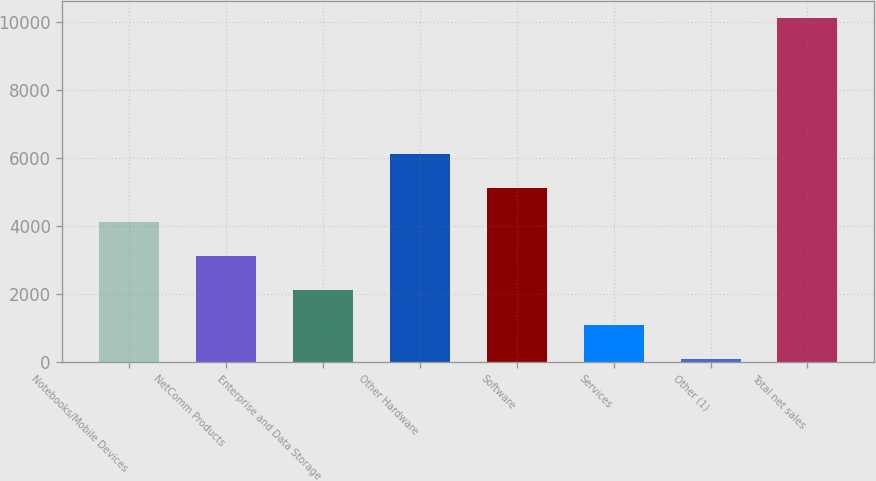<chart> <loc_0><loc_0><loc_500><loc_500><bar_chart><fcel>Notebooks/Mobile Devices<fcel>NetComm Products<fcel>Enterprise and Data Storage<fcel>Other Hardware<fcel>Software<fcel>Services<fcel>Other (1)<fcel>Total net sales<nl><fcel>4107.68<fcel>3104.26<fcel>2100.84<fcel>6114.52<fcel>5111.1<fcel>1097.42<fcel>94<fcel>10128.2<nl></chart> 